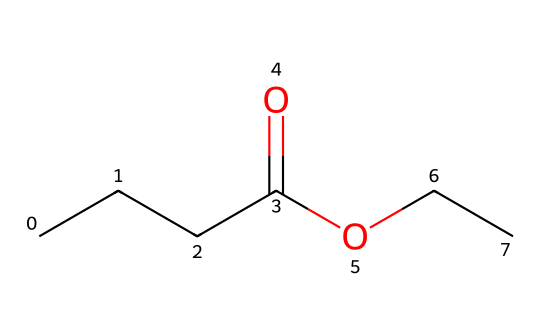What is the molecular formula of ethyl butyrate? The SMILES representation indicates the presence of 4 carbon atoms from the butyrate part (CCCC) and 2 from the ethyl part (C), along with oxygen from the carboxylate (O) and ether (O) groups. When combined, the total counts are C6, H12, and O2. Thus, the molecular formula is C6H12O2.
Answer: C6H12O2 How many carbon atoms are in ethyl butyrate? Analyzing the SMILES representation, there are four carbon atoms from the butyric acid portion (CCCC) and two from the ethyl group (CC), which adds up to six total carbon atoms.
Answer: 6 What functional groups are present in this ester? The SMILES shows that the chemical has both a carboxylate group (from butyric acid) and an ether group (from the ethyl group). Specifically, there’s a carbonyl (C=O) and an ether (–O–) functional group indicative of esters.
Answer: carboxylate and ether Is ethyl butyrate a saturated or unsaturated compound? The compound's structure does not contain any double or triple bonds that would characterize unsaturation (besides the carbonyl bond which doesn't count in this context). Therefore, all carbon-carbon connections are single bonds, indicating that ethyl butyrate is a saturated compound.
Answer: saturated What is the role of ethyl butyrate in cat food? As an ester, ethyl butyrate contributes to flavor profiles in cat food, providing fruit-like or tropical notes, which can enhance palatability for cats.
Answer: flavoring agent How many oxygen atoms are in the chemical structure of ethyl butyrate? The SMILES includes two oxygen atoms: one in the carbonyl group and another in the ether part of the molecule. Therefore, the total number of oxygen atoms is two.
Answer: 2 